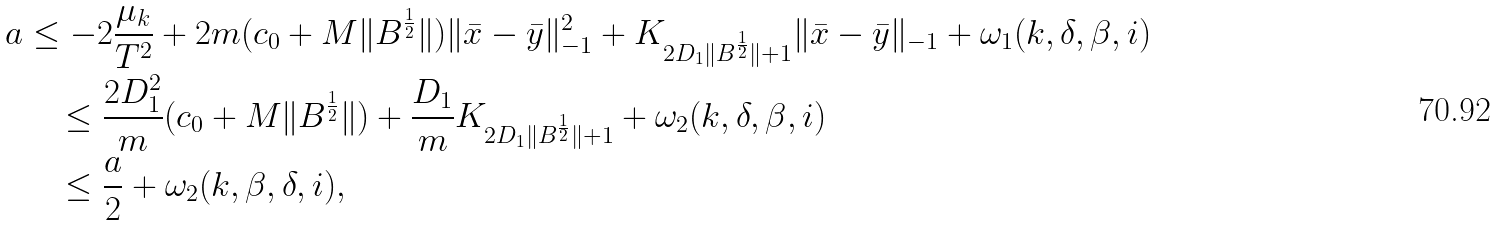<formula> <loc_0><loc_0><loc_500><loc_500>a & \leq - 2 \frac { \mu _ { k } } { T ^ { 2 } } + 2 m ( c _ { 0 } + M \| B ^ { \frac { 1 } { 2 } } \| ) \| \bar { x } - \bar { y } \| _ { - 1 } ^ { 2 } + K _ { 2 D _ { 1 } \| B ^ { \frac { 1 } { 2 } } \| + 1 } \| \bar { x } - \bar { y } \| _ { - 1 } + \omega _ { 1 } ( k , \delta , \beta , i ) \\ & \quad \leq \frac { 2 D _ { 1 } ^ { 2 } } { m } ( c _ { 0 } + M \| B ^ { \frac { 1 } { 2 } } \| ) + \frac { D _ { 1 } } { m } K _ { 2 D _ { 1 } \| B ^ { \frac { 1 } { 2 } } \| + 1 } + \omega _ { 2 } ( k , \delta , \beta , i ) \\ & \quad \leq \frac { a } { 2 } + \omega _ { 2 } ( k , \beta , \delta , i ) ,</formula> 